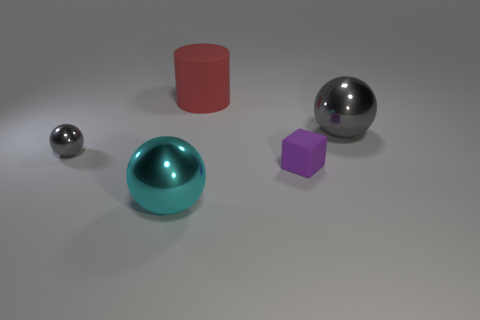What is the material of the gray sphere left of the big metallic object that is to the right of the large cyan ball?
Make the answer very short. Metal. What is the shape of the other thing that is the same color as the small metallic thing?
Make the answer very short. Sphere. There is a thing that is the same size as the cube; what is its shape?
Provide a succinct answer. Sphere. Is the number of red rubber cylinders less than the number of balls?
Make the answer very short. Yes. Are there any small gray metal objects that are right of the small object that is to the left of the large cyan object?
Give a very brief answer. No. The purple thing that is the same material as the red cylinder is what shape?
Your answer should be compact. Cube. Is there anything else that is the same color as the tiny sphere?
Offer a terse response. Yes. There is another large thing that is the same shape as the large cyan metal thing; what is it made of?
Ensure brevity in your answer.  Metal. What number of other things are there of the same size as the red cylinder?
Offer a very short reply. 2. There is a metal thing that is the same color as the small metallic sphere; what is its size?
Your answer should be very brief. Large. 